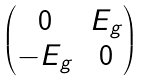<formula> <loc_0><loc_0><loc_500><loc_500>\begin{pmatrix} 0 & E _ { g } \\ - E _ { g } & 0 \end{pmatrix}</formula> 